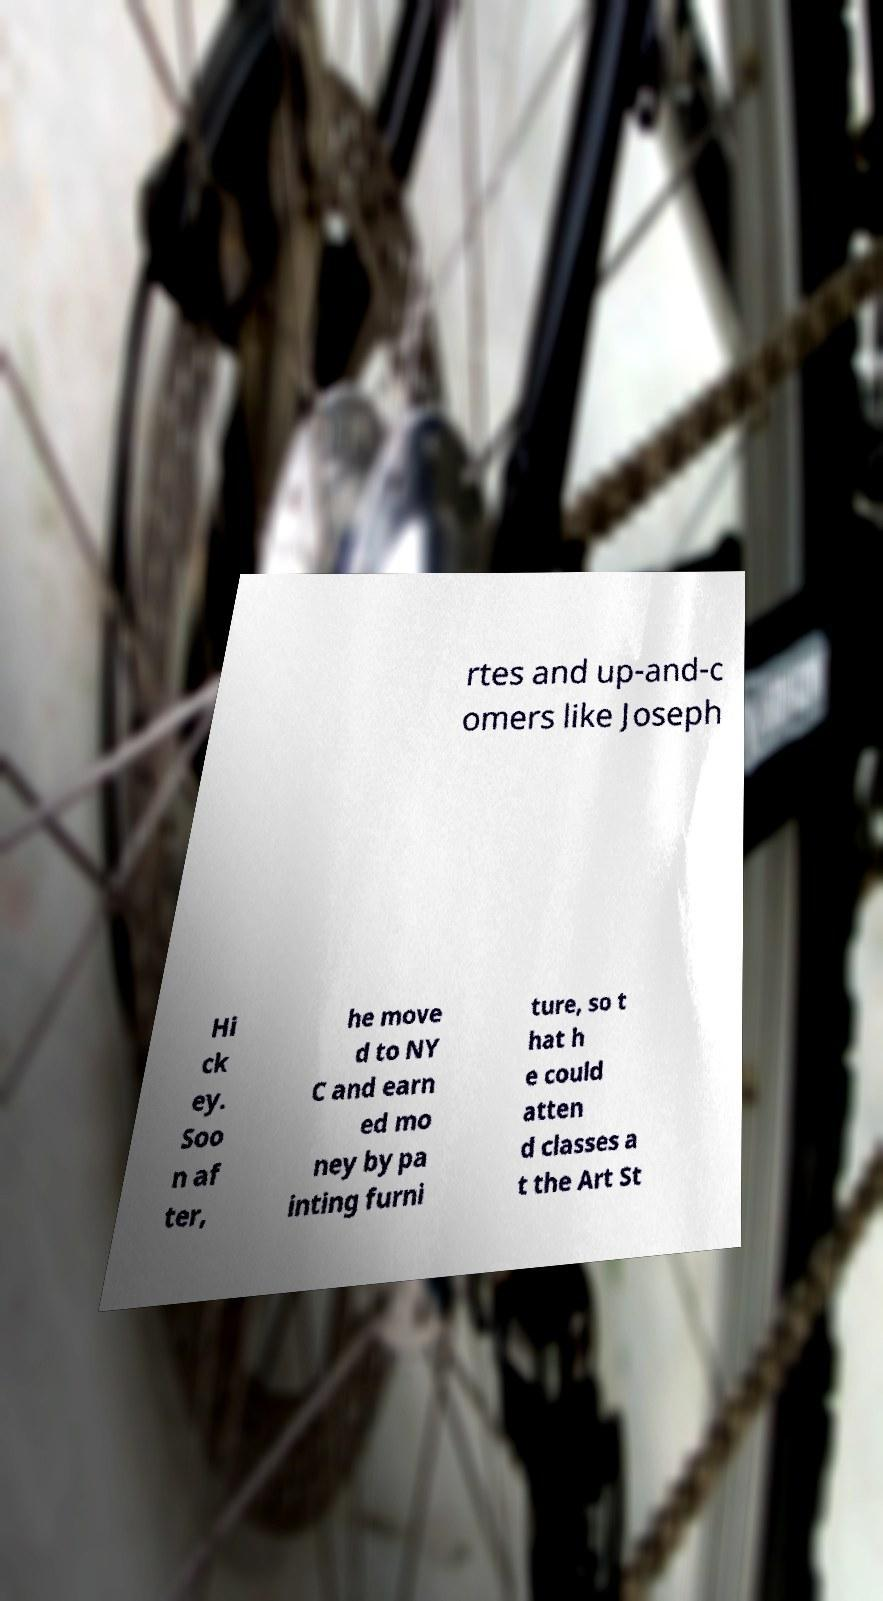Can you accurately transcribe the text from the provided image for me? rtes and up-and-c omers like Joseph Hi ck ey. Soo n af ter, he move d to NY C and earn ed mo ney by pa inting furni ture, so t hat h e could atten d classes a t the Art St 